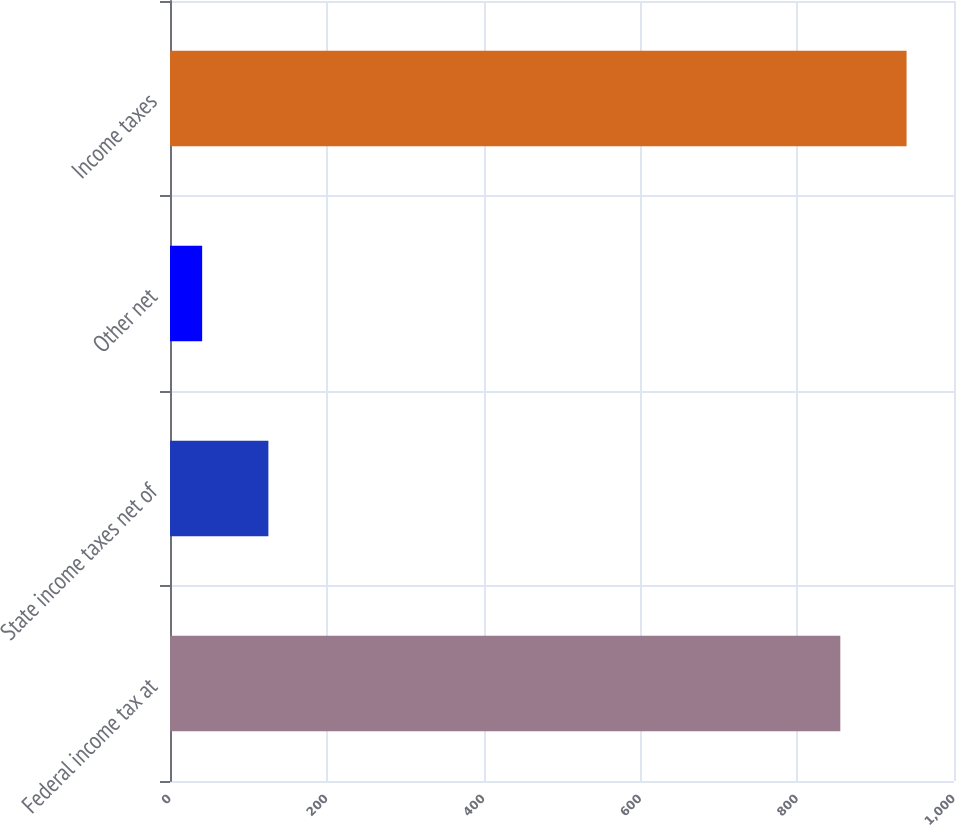Convert chart. <chart><loc_0><loc_0><loc_500><loc_500><bar_chart><fcel>Federal income tax at<fcel>State income taxes net of<fcel>Other net<fcel>Income taxes<nl><fcel>855<fcel>125.5<fcel>41<fcel>939.5<nl></chart> 